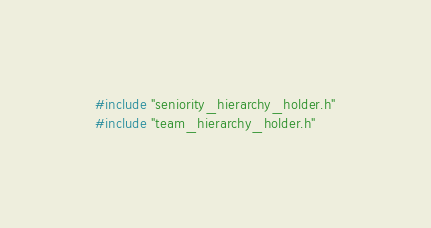Convert code to text. <code><loc_0><loc_0><loc_500><loc_500><_C++_>#include "seniority_hierarchy_holder.h"
#include "team_hierarchy_holder.h"</code> 